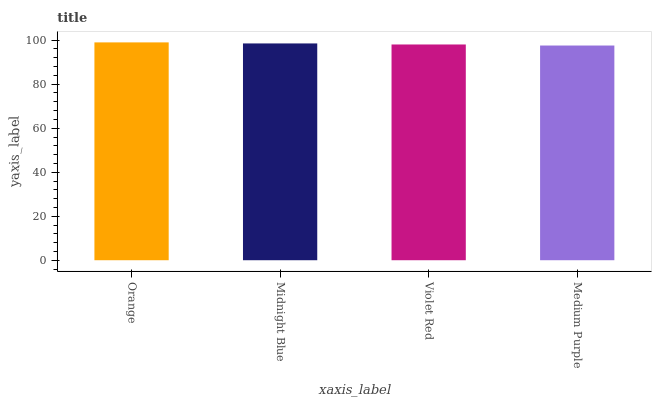Is Medium Purple the minimum?
Answer yes or no. Yes. Is Orange the maximum?
Answer yes or no. Yes. Is Midnight Blue the minimum?
Answer yes or no. No. Is Midnight Blue the maximum?
Answer yes or no. No. Is Orange greater than Midnight Blue?
Answer yes or no. Yes. Is Midnight Blue less than Orange?
Answer yes or no. Yes. Is Midnight Blue greater than Orange?
Answer yes or no. No. Is Orange less than Midnight Blue?
Answer yes or no. No. Is Midnight Blue the high median?
Answer yes or no. Yes. Is Violet Red the low median?
Answer yes or no. Yes. Is Medium Purple the high median?
Answer yes or no. No. Is Orange the low median?
Answer yes or no. No. 